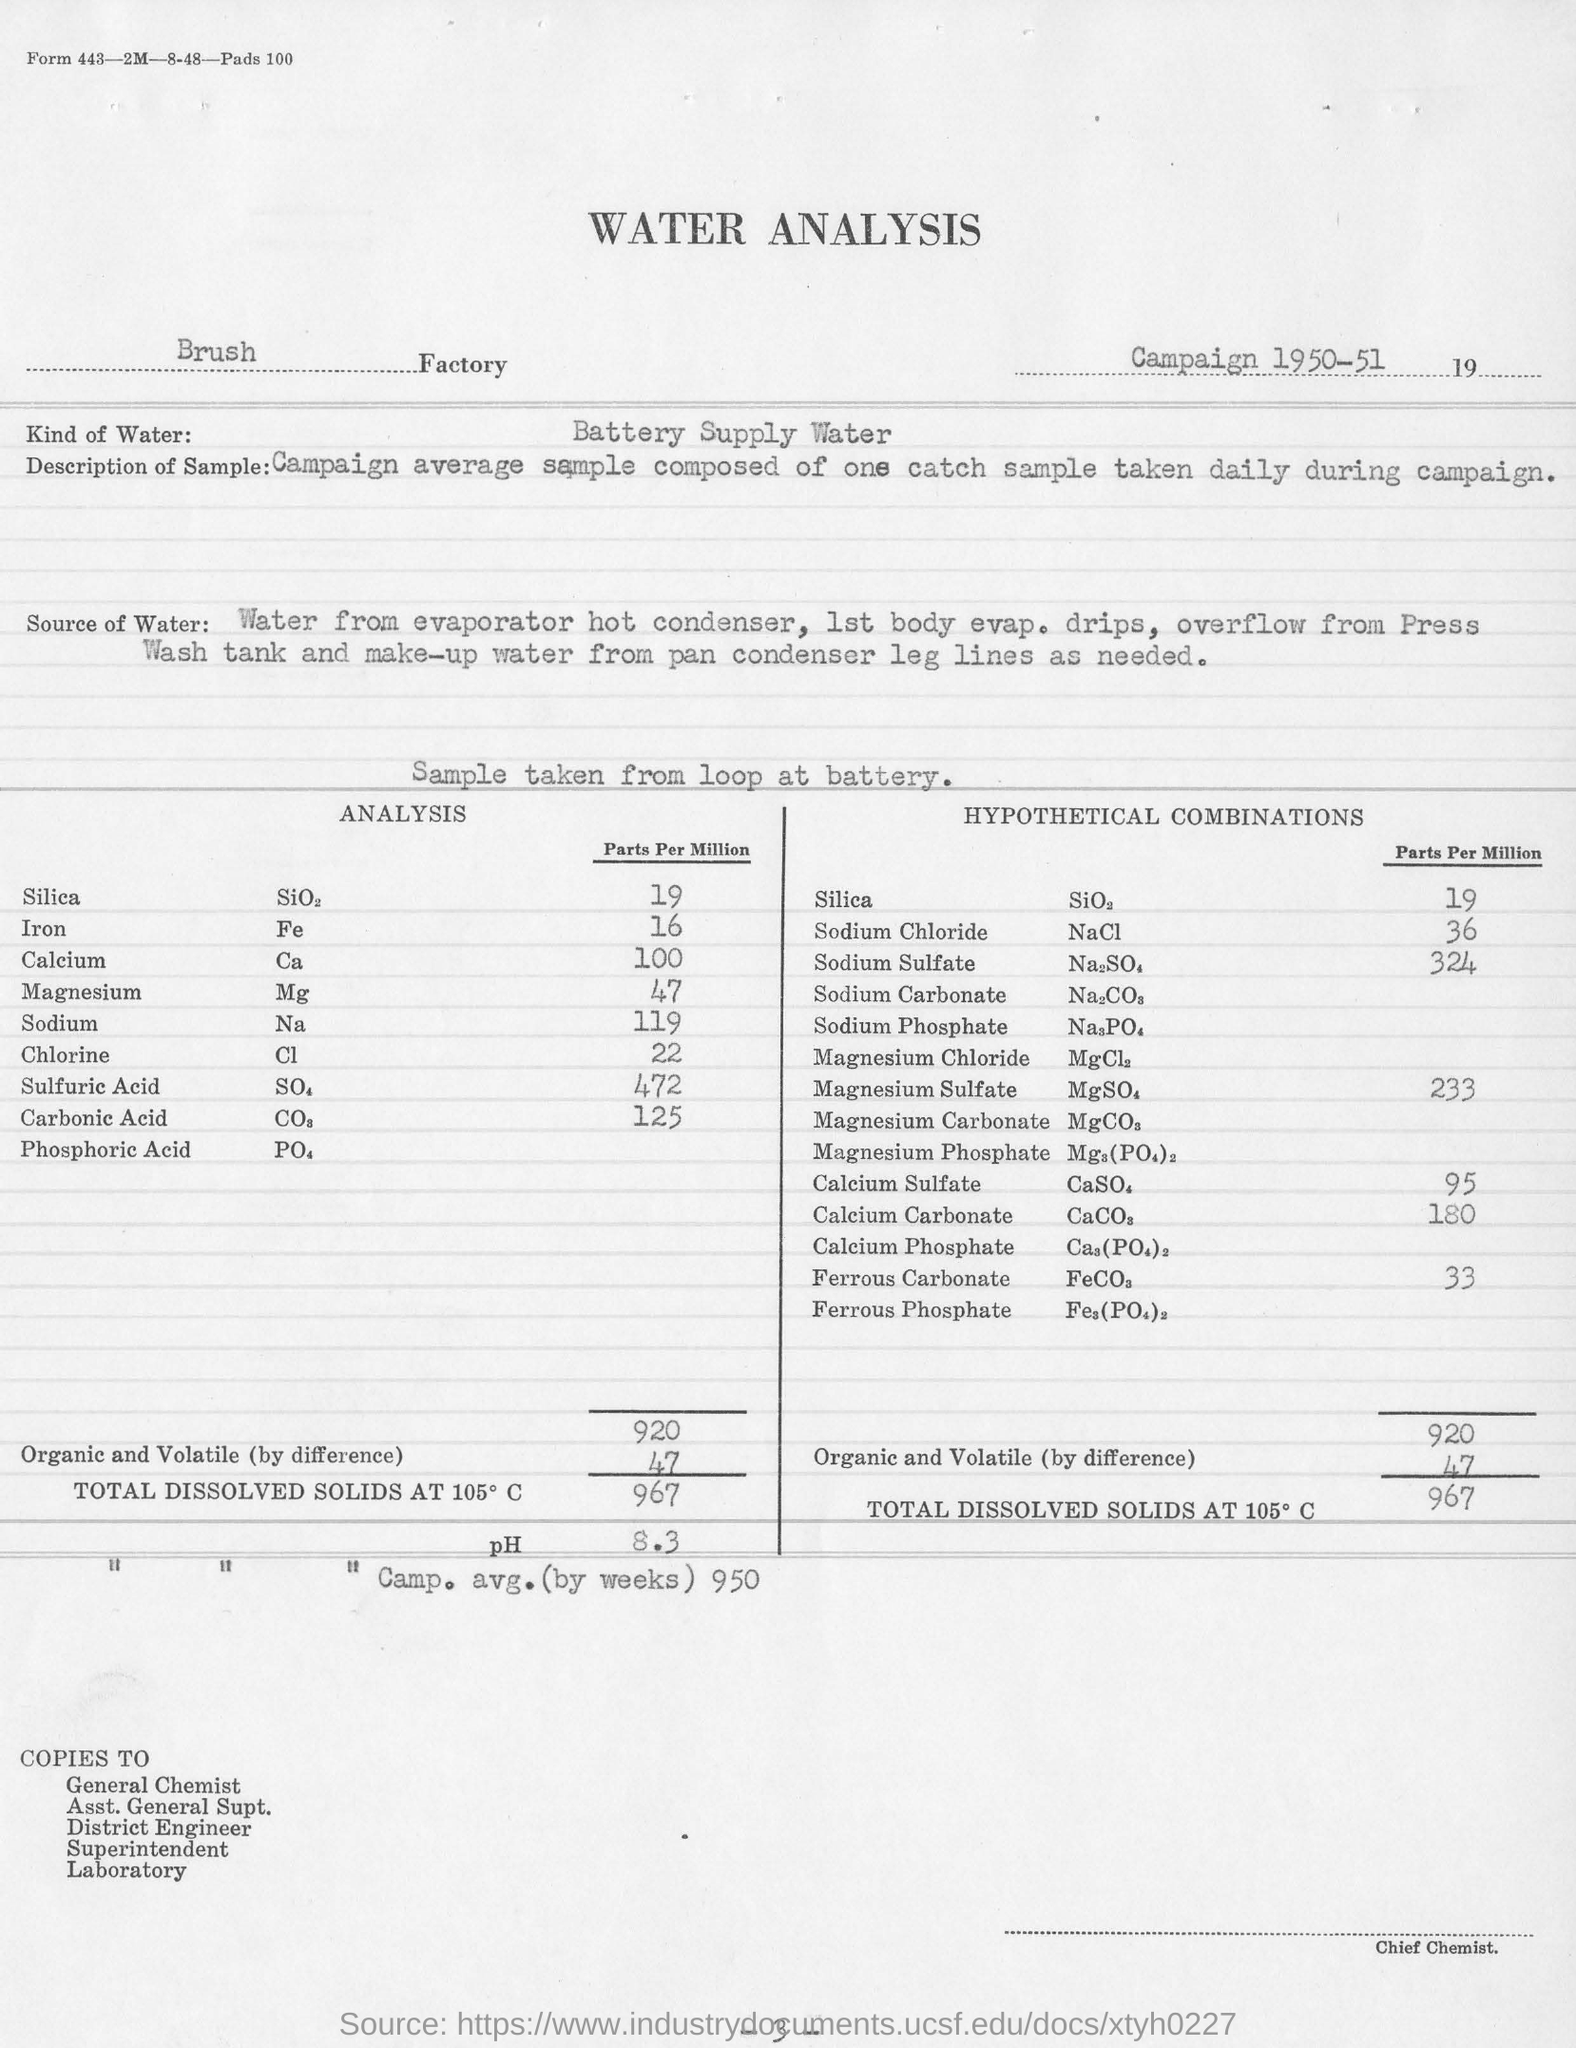Indicate a few pertinent items in this graphic. The water sample was taken from the loop at the battery. In hypothetical combinations, the amount of Calcium Sulphate at 95 parts per million is [insert value here]. The water analysis was conducted by the Brush Factory. It is known that a type of water commonly used for analysis in battery supply is referred to as Battery Supply Water. 